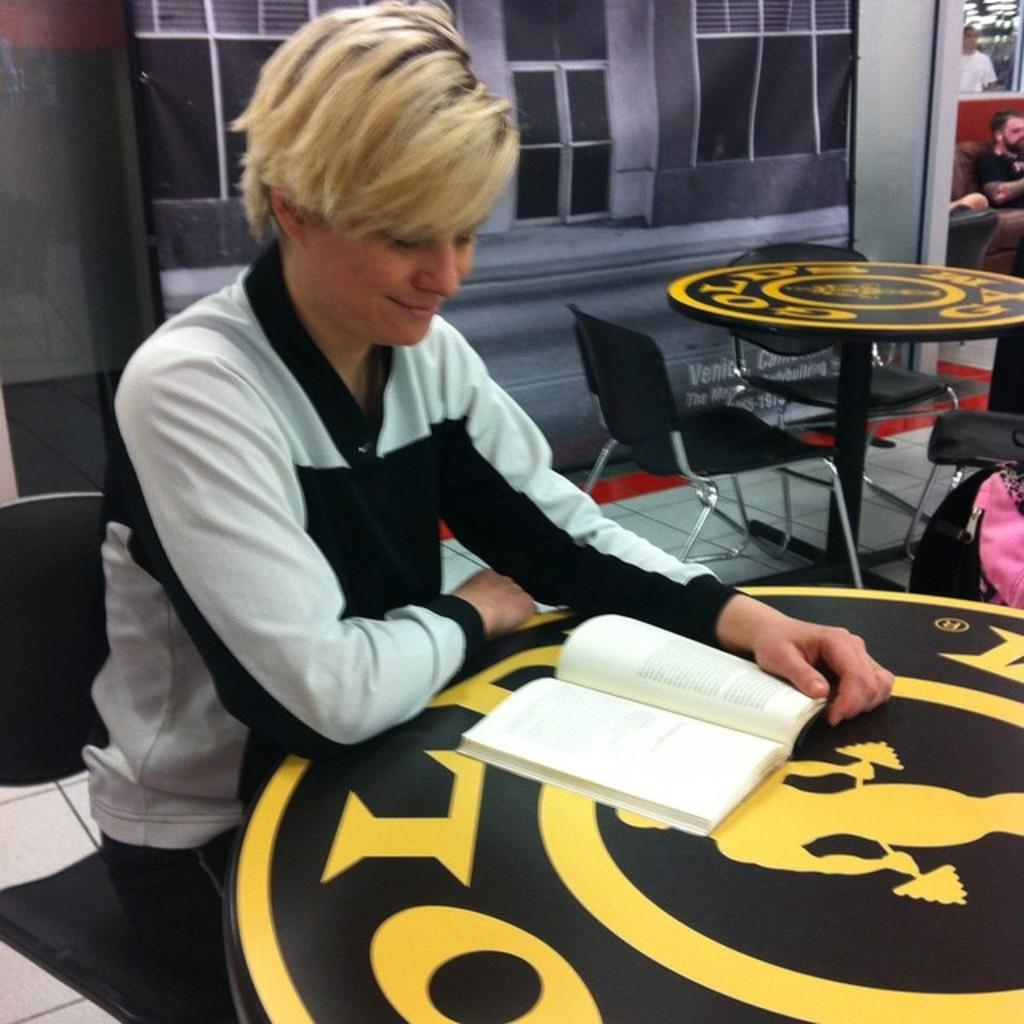What type of furniture can be seen in the image? There are chairs and tables in the image. What is hanging or attached to the wall in the image? There is a banner in the image. What are the two persons sitting on? The two persons are sitting on chairs. What is the person holding in the image? One person is holding a book. Can you describe the person standing in the background? There is another person standing in the background. What type of ghost can be seen interacting with the book in the image? There is no ghost present in the image; it features two persons sitting and one person standing. What type of quartz is visible on the table in the image? There is no quartz present in the image; it features a book and other items on the table. 